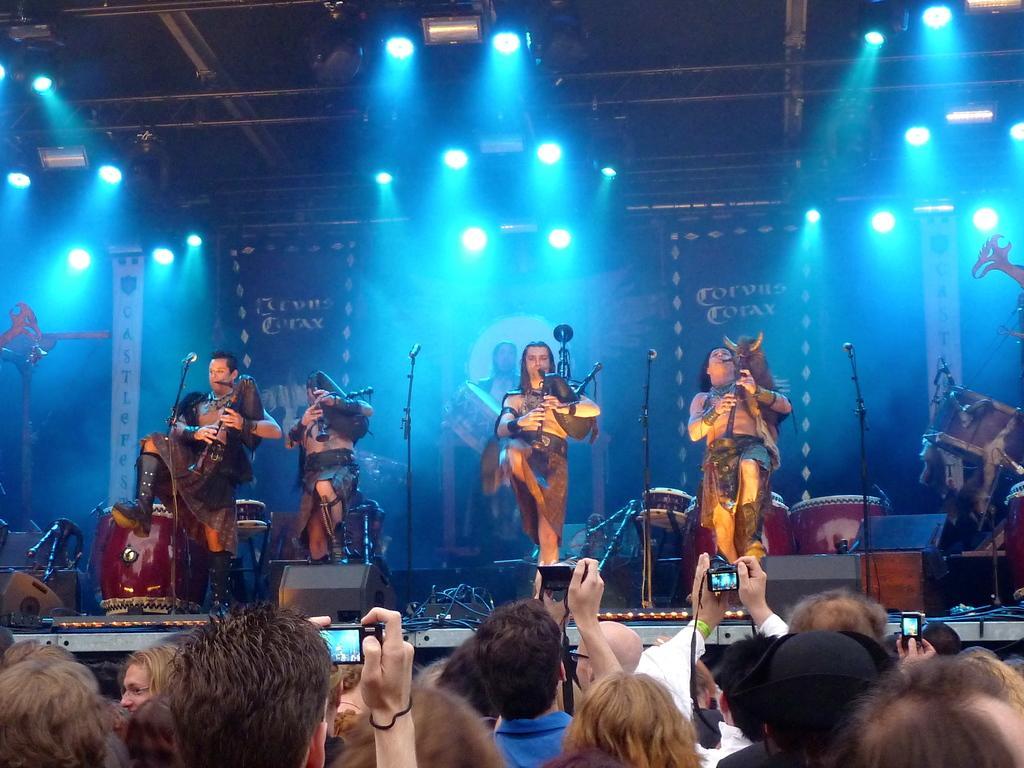Can you describe this image briefly? This picture shows a group of people performing with the musical instruments on the dais and we see microphones in front of them and few are holding trumpets and a man holding a piano in his hand and we see lights on the roof and we see drums and guitar on the side and we see audience taking pictures with the cameras 